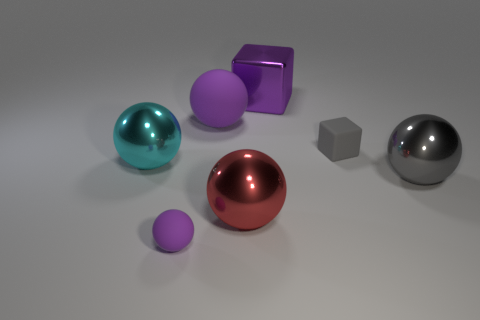What number of yellow rubber things are there?
Your response must be concise. 0. Is the material of the tiny thing that is in front of the big red metal sphere the same as the big purple thing in front of the big purple metal block?
Give a very brief answer. Yes. There is a red ball that is made of the same material as the large purple cube; what is its size?
Your answer should be compact. Large. There is a shiny thing right of the big metallic block; what is its shape?
Keep it short and to the point. Sphere. Is the color of the rubber sphere that is behind the red sphere the same as the matte thing in front of the tiny gray rubber thing?
Your answer should be very brief. Yes. What size is the other matte ball that is the same color as the tiny sphere?
Your answer should be very brief. Large. Are any big yellow metal cubes visible?
Provide a short and direct response. No. What is the shape of the shiny object that is behind the tiny matte thing that is behind the gray object in front of the large cyan thing?
Ensure brevity in your answer.  Cube. There is a cyan metal thing; what number of rubber objects are in front of it?
Offer a terse response. 1. Is the material of the big object in front of the big gray metal ball the same as the big gray object?
Give a very brief answer. Yes. 